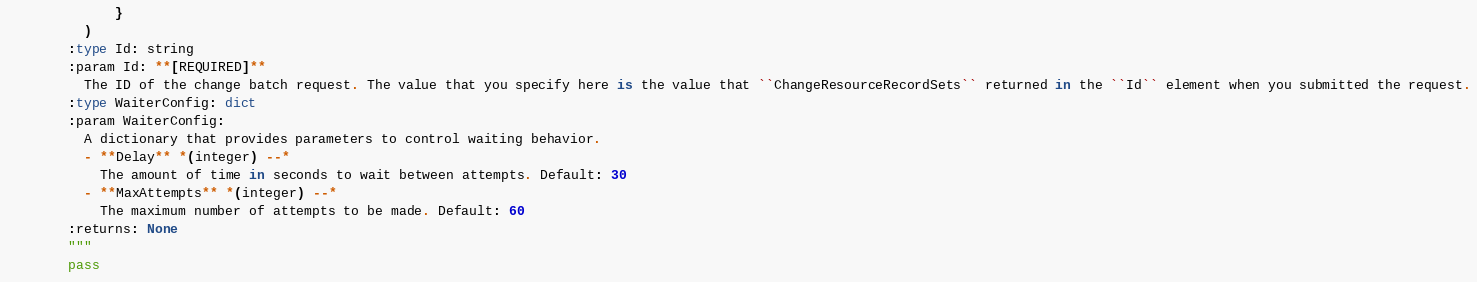Convert code to text. <code><loc_0><loc_0><loc_500><loc_500><_Python_>              }
          )
        :type Id: string
        :param Id: **[REQUIRED]**
          The ID of the change batch request. The value that you specify here is the value that ``ChangeResourceRecordSets`` returned in the ``Id`` element when you submitted the request.
        :type WaiterConfig: dict
        :param WaiterConfig:
          A dictionary that provides parameters to control waiting behavior.
          - **Delay** *(integer) --*
            The amount of time in seconds to wait between attempts. Default: 30
          - **MaxAttempts** *(integer) --*
            The maximum number of attempts to be made. Default: 60
        :returns: None
        """
        pass
</code> 